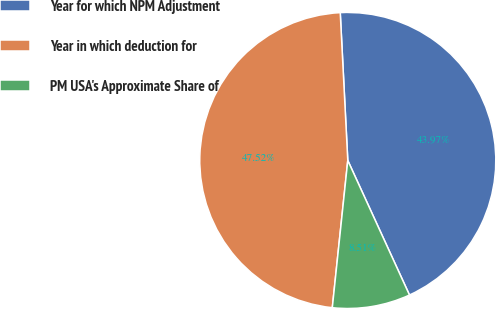Convert chart to OTSL. <chart><loc_0><loc_0><loc_500><loc_500><pie_chart><fcel>Year for which NPM Adjustment<fcel>Year in which deduction for<fcel>PM USA's Approximate Share of<nl><fcel>43.97%<fcel>47.52%<fcel>8.51%<nl></chart> 